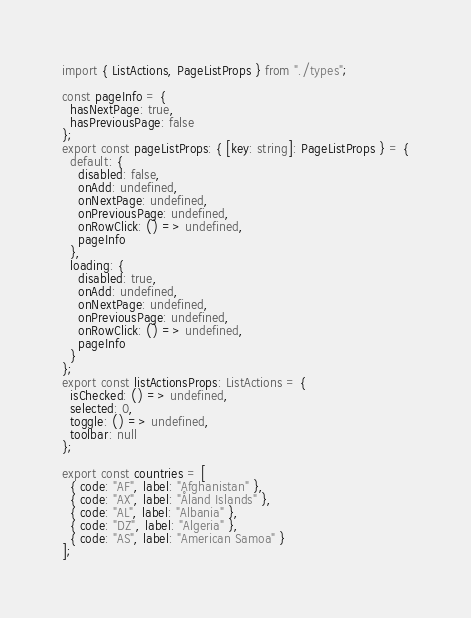<code> <loc_0><loc_0><loc_500><loc_500><_TypeScript_>import { ListActions, PageListProps } from "./types";

const pageInfo = {
  hasNextPage: true,
  hasPreviousPage: false
};
export const pageListProps: { [key: string]: PageListProps } = {
  default: {
    disabled: false,
    onAdd: undefined,
    onNextPage: undefined,
    onPreviousPage: undefined,
    onRowClick: () => undefined,
    pageInfo
  },
  loading: {
    disabled: true,
    onAdd: undefined,
    onNextPage: undefined,
    onPreviousPage: undefined,
    onRowClick: () => undefined,
    pageInfo
  }
};
export const listActionsProps: ListActions = {
  isChecked: () => undefined,
  selected: 0,
  toggle: () => undefined,
  toolbar: null
};

export const countries = [
  { code: "AF", label: "Afghanistan" },
  { code: "AX", label: "Åland Islands" },
  { code: "AL", label: "Albania" },
  { code: "DZ", label: "Algeria" },
  { code: "AS", label: "American Samoa" }
];
</code> 